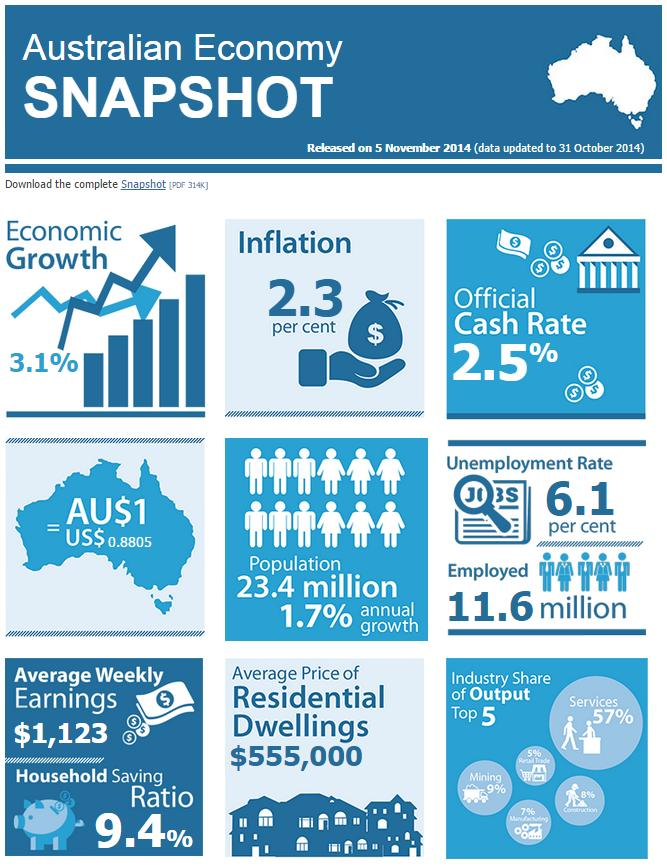List a handful of essential elements in this visual. Construction has the highest industry share among manufacturing, construction, and retail trade. The mining industry has the second highest share of output among all industries in the economy. One Australian dollar is equivalent to 0.8805 dollars in the United States. 